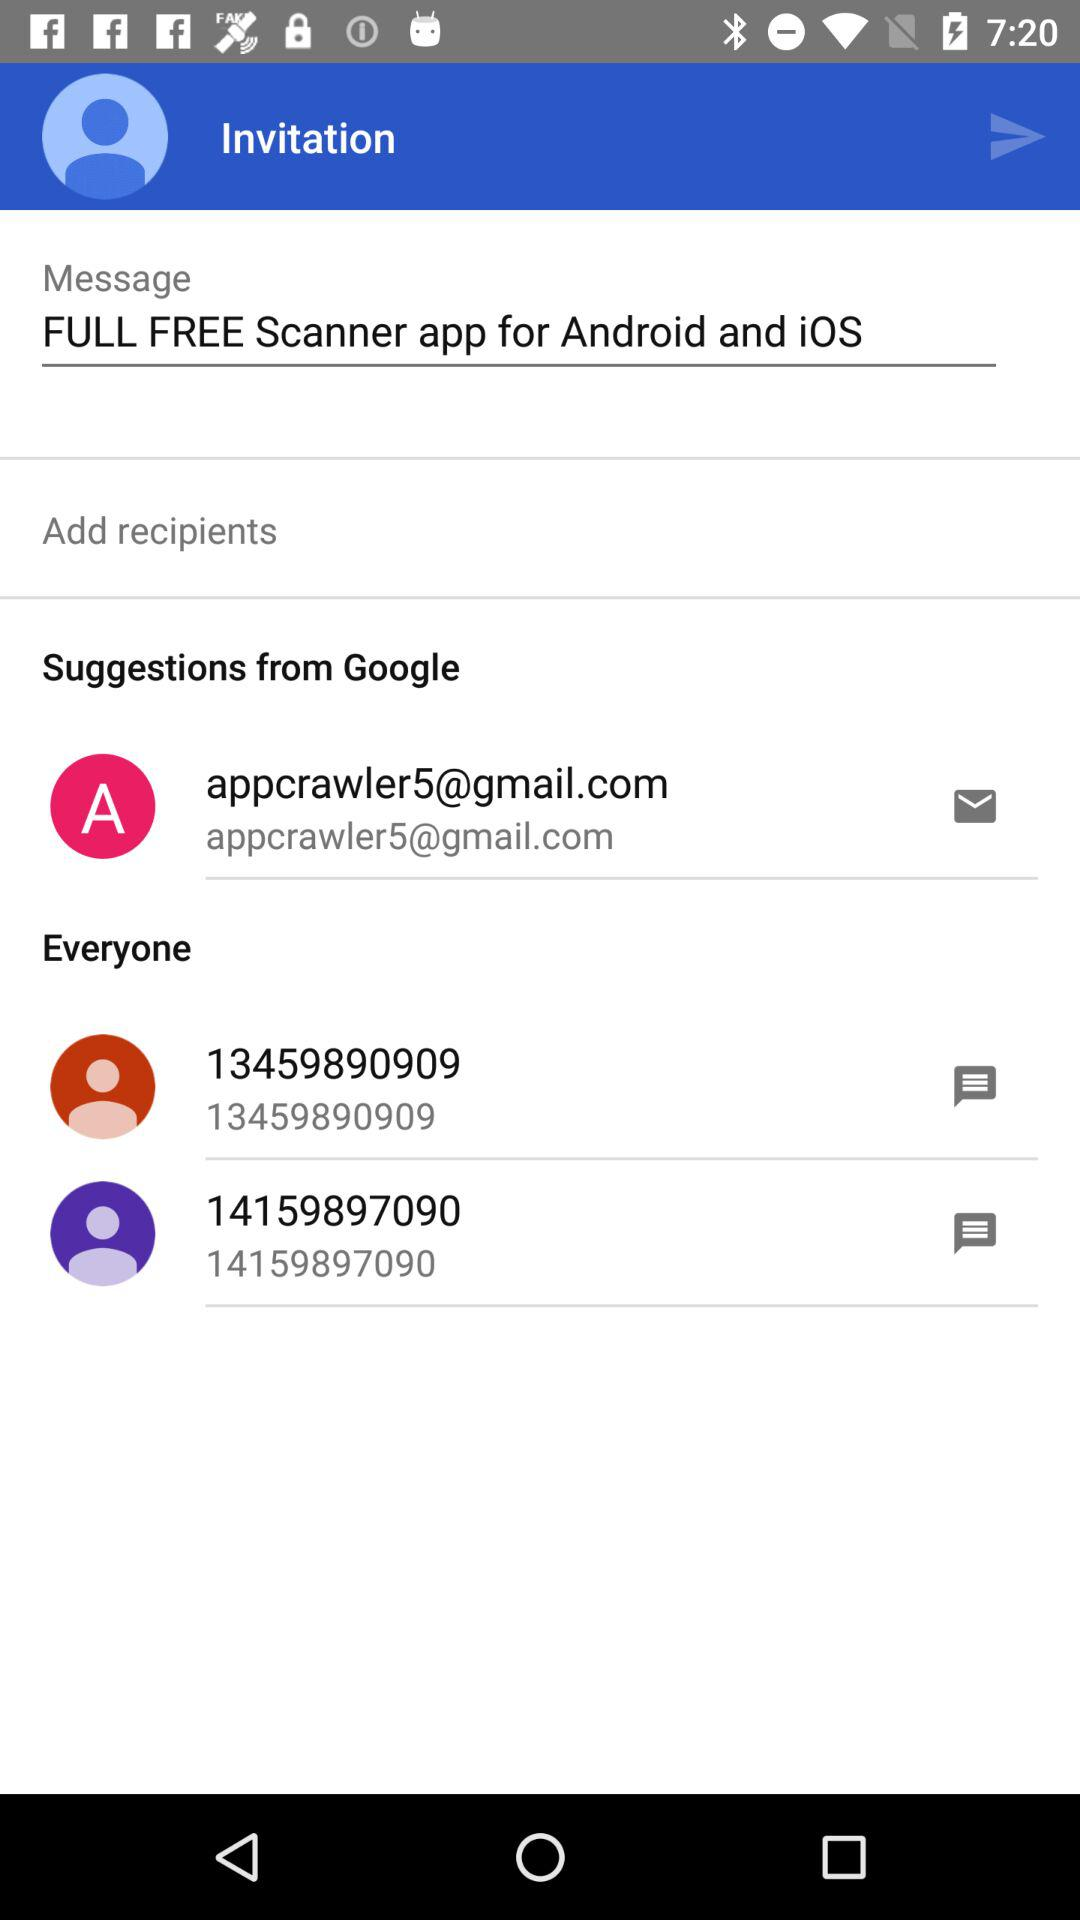What is the displayed email address? The displayed email address is appcrawler5@gmail.com. 